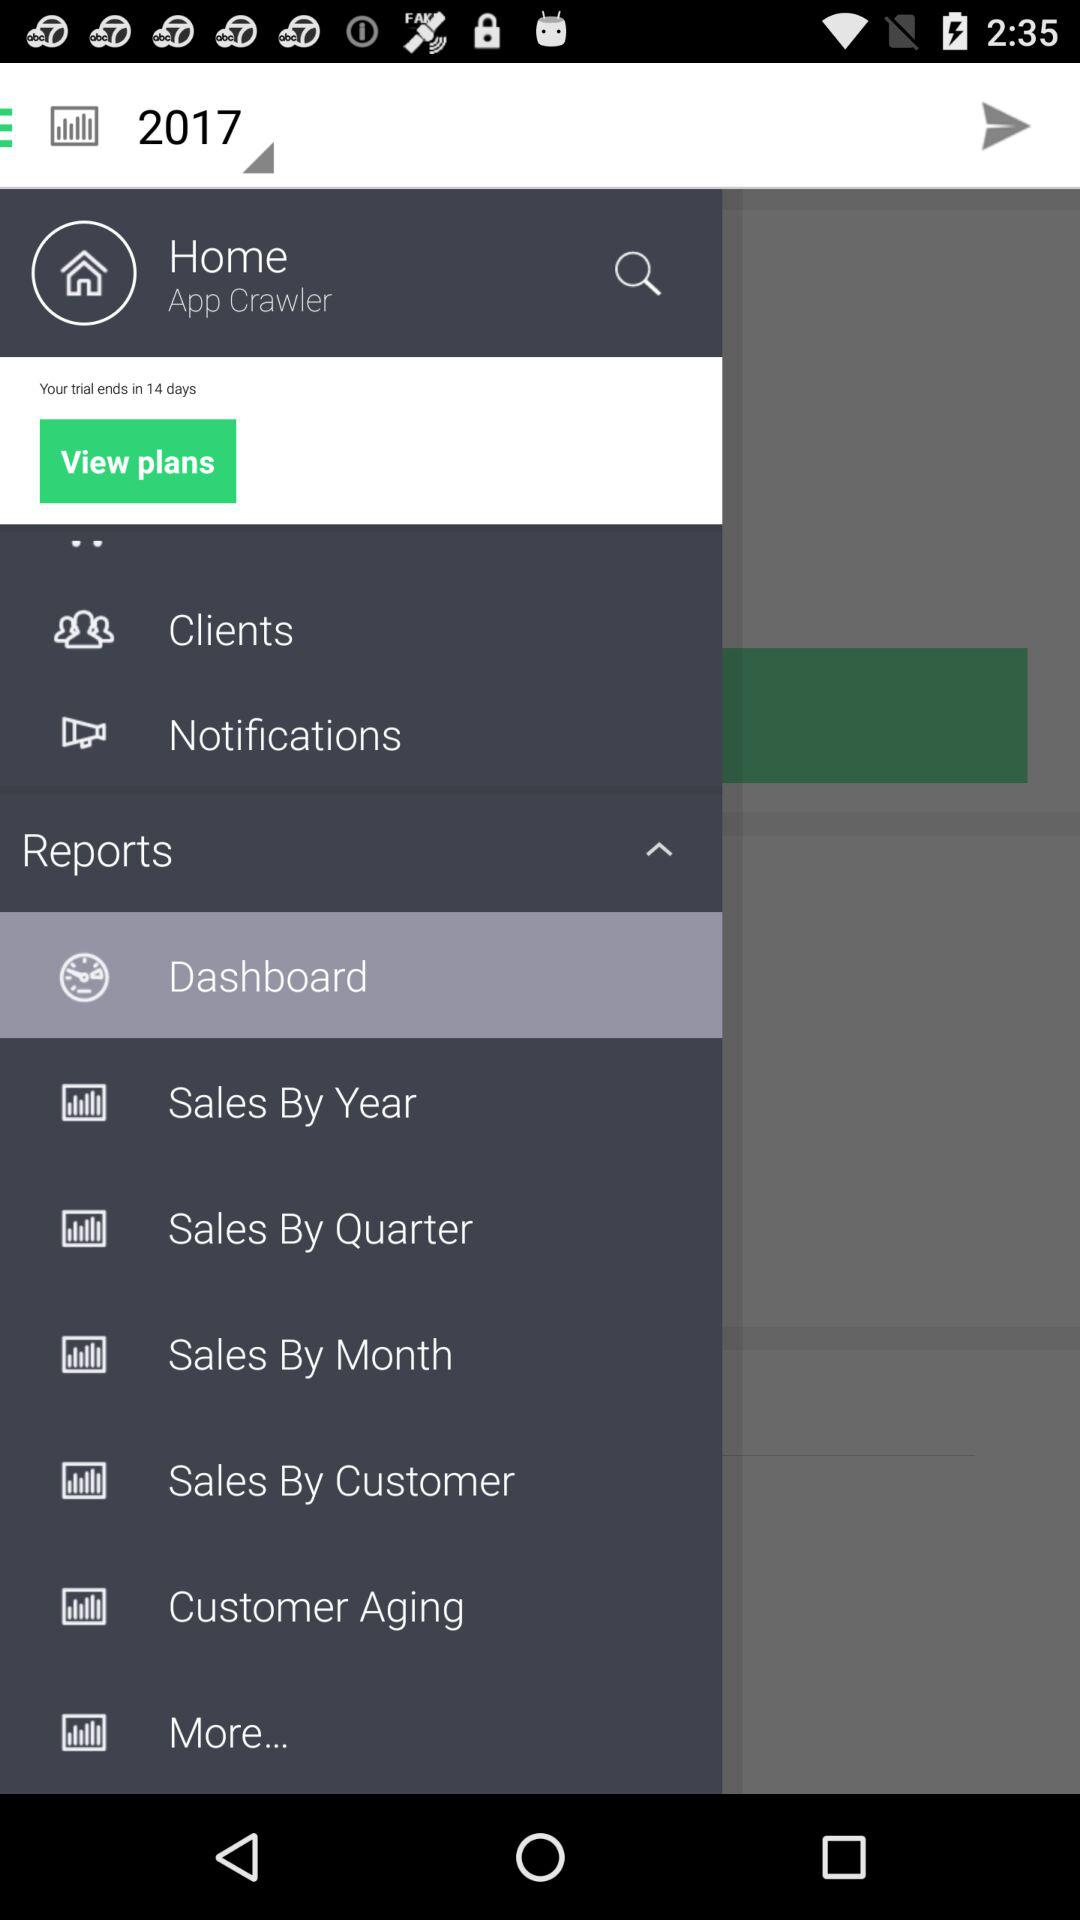Which item is selected in the menu? The item "Dashboard" is selected in the menu. 